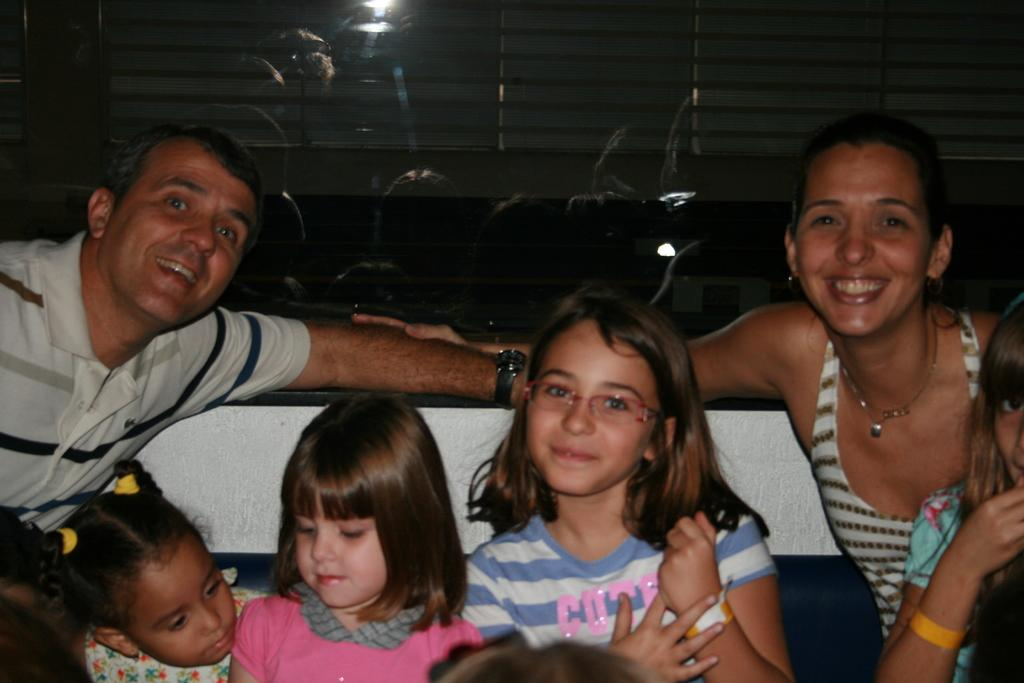What are the people in the image doing? The people in the image are sitting on a couch. What can be seen in the image besides the people on the couch? The people are reflected in a mirror in the image. What is the source of light in the image? There is a light visible in the image. What type of rake is being used by the people in the image? There is no rake present in the image; the people are sitting on a couch and reflected in a mirror. 